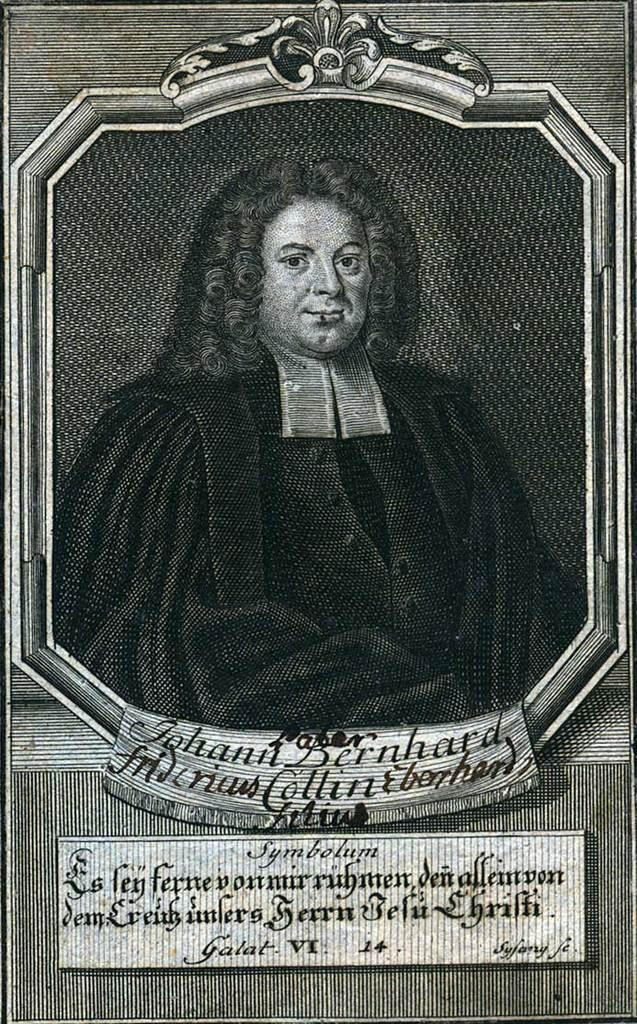What is present on the poster in the image? There is a poster in the image, which contains an image of a person. What else can be seen on the poster besides the image? There is text on the poster. What type of expansion is being advertised on the poster? There is no mention of any expansion on the poster; it only contains an image of a person and text. 